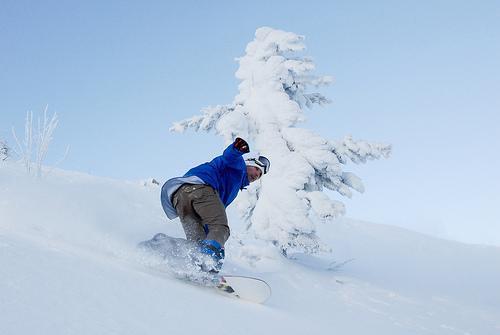How many people?
Give a very brief answer. 1. 